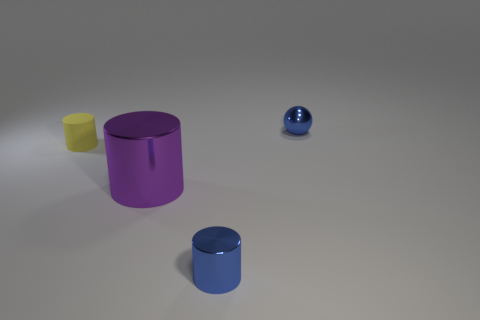Add 3 shiny things. How many objects exist? 7 Subtract all metal cylinders. How many cylinders are left? 1 Subtract all yellow cylinders. How many cylinders are left? 2 Subtract all spheres. How many objects are left? 3 Subtract all gray balls. How many purple cylinders are left? 1 Subtract all purple metallic cylinders. Subtract all small matte cylinders. How many objects are left? 2 Add 1 rubber cylinders. How many rubber cylinders are left? 2 Add 1 yellow metal things. How many yellow metal things exist? 1 Subtract 0 blue cubes. How many objects are left? 4 Subtract all green balls. Subtract all yellow cylinders. How many balls are left? 1 